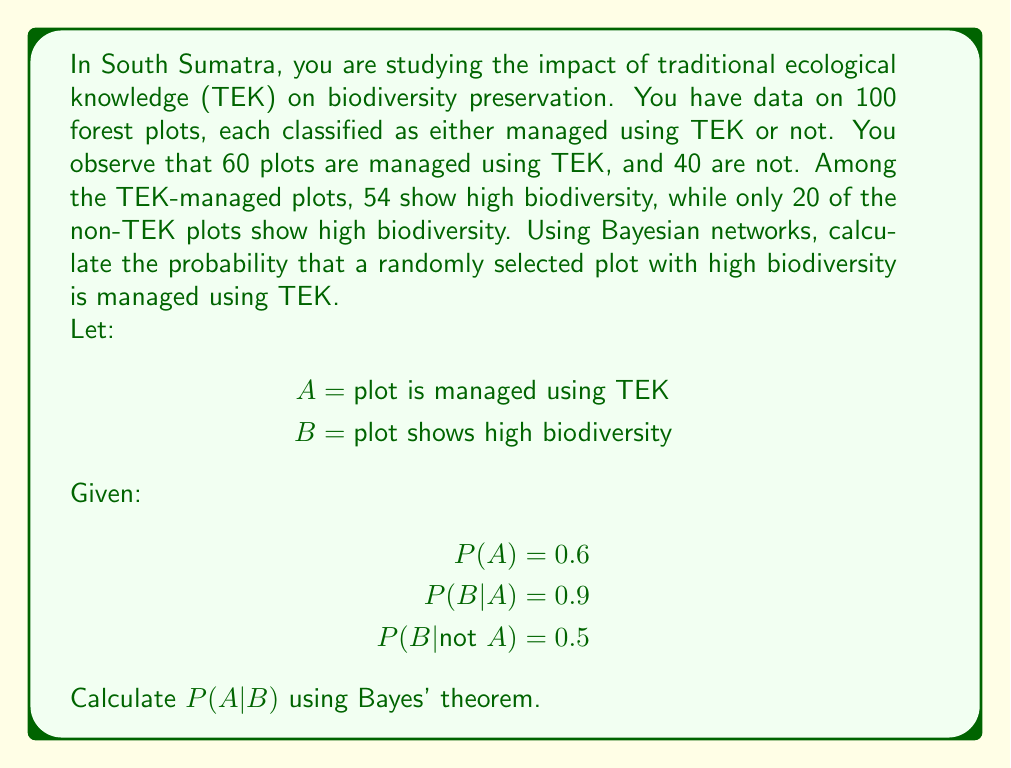Provide a solution to this math problem. To solve this problem, we'll use Bayes' theorem, which is given by:

$$P(A|B) = \frac{P(B|A) \cdot P(A)}{P(B)}$$

We're given:
P(A) = 0.6 (probability of a plot being managed using TEK)
P(B|A) = 0.9 (probability of high biodiversity given TEK management)
P(B|not A) = 0.5 (probability of high biodiversity given non-TEK management)

Step 1: Calculate P(B) using the law of total probability
$$P(B) = P(B|A) \cdot P(A) + P(B|not A) \cdot P(not A)$$
$$P(B) = 0.9 \cdot 0.6 + 0.5 \cdot (1 - 0.6)$$
$$P(B) = 0.54 + 0.2 = 0.74$$

Step 2: Apply Bayes' theorem
$$P(A|B) = \frac{P(B|A) \cdot P(A)}{P(B)}$$
$$P(A|B) = \frac{0.9 \cdot 0.6}{0.74}$$
$$P(A|B) = \frac{0.54}{0.74}$$
$$P(A|B) \approx 0.7297$$

Therefore, the probability that a randomly selected plot with high biodiversity is managed using TEK is approximately 0.7297 or 72.97%.
Answer: P(A|B) ≈ 0.7297 or 72.97% 